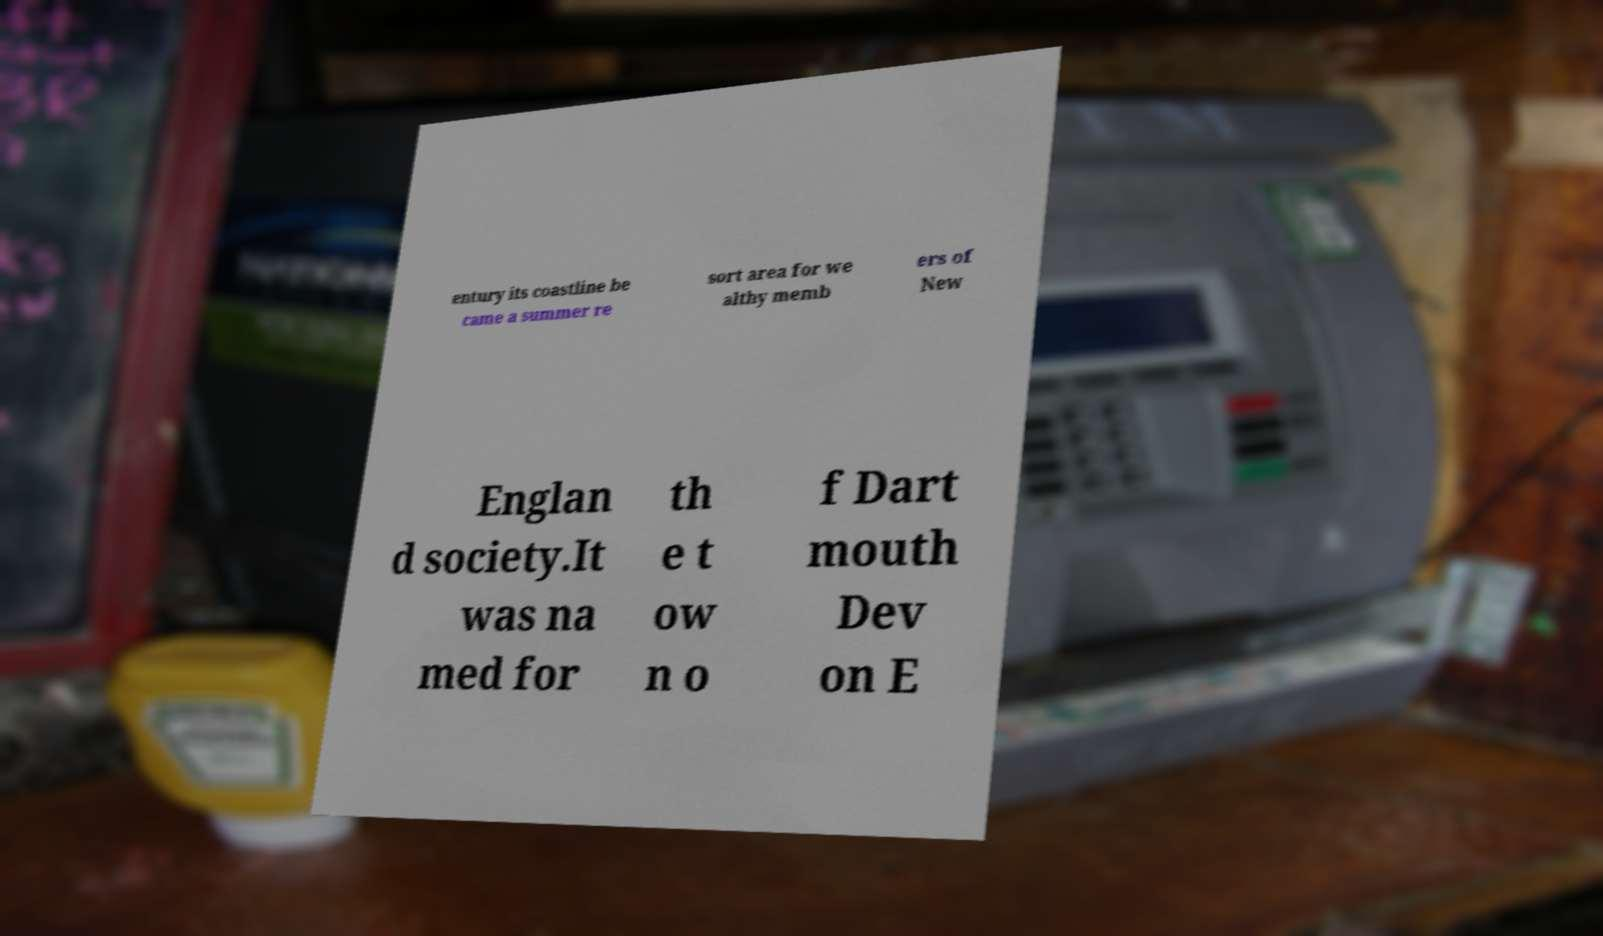What messages or text are displayed in this image? I need them in a readable, typed format. entury its coastline be came a summer re sort area for we althy memb ers of New Englan d society.It was na med for th e t ow n o f Dart mouth Dev on E 